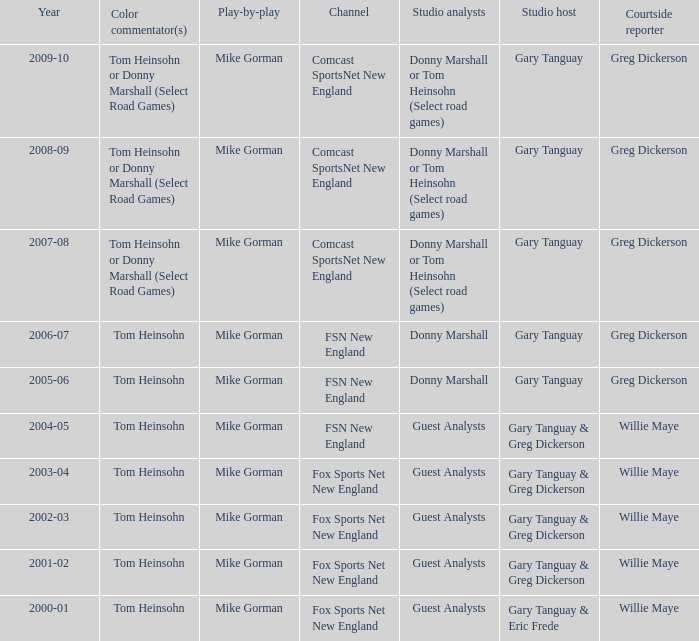Which Courtside reporter has a Channel of fsn new england in 2006-07? Greg Dickerson. 